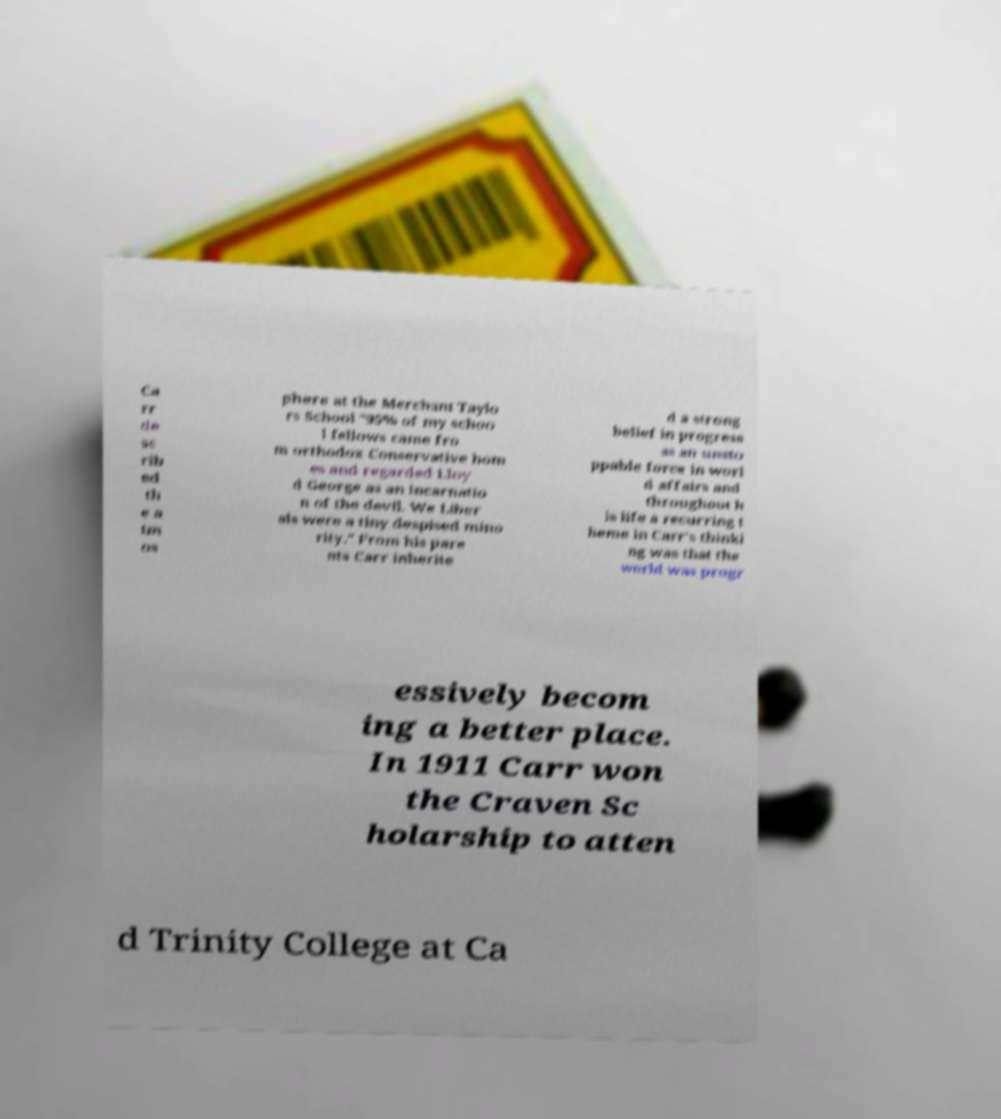Can you read and provide the text displayed in the image?This photo seems to have some interesting text. Can you extract and type it out for me? Ca rr de sc rib ed th e a tm os phere at the Merchant Taylo rs School "95% of my schoo l fellows came fro m orthodox Conservative hom es and regarded Lloy d George as an incarnatio n of the devil. We Liber als were a tiny despised mino rity." From his pare nts Carr inherite d a strong belief in progress as an unsto ppable force in worl d affairs and throughout h is life a recurring t heme in Carr's thinki ng was that the world was progr essively becom ing a better place. In 1911 Carr won the Craven Sc holarship to atten d Trinity College at Ca 